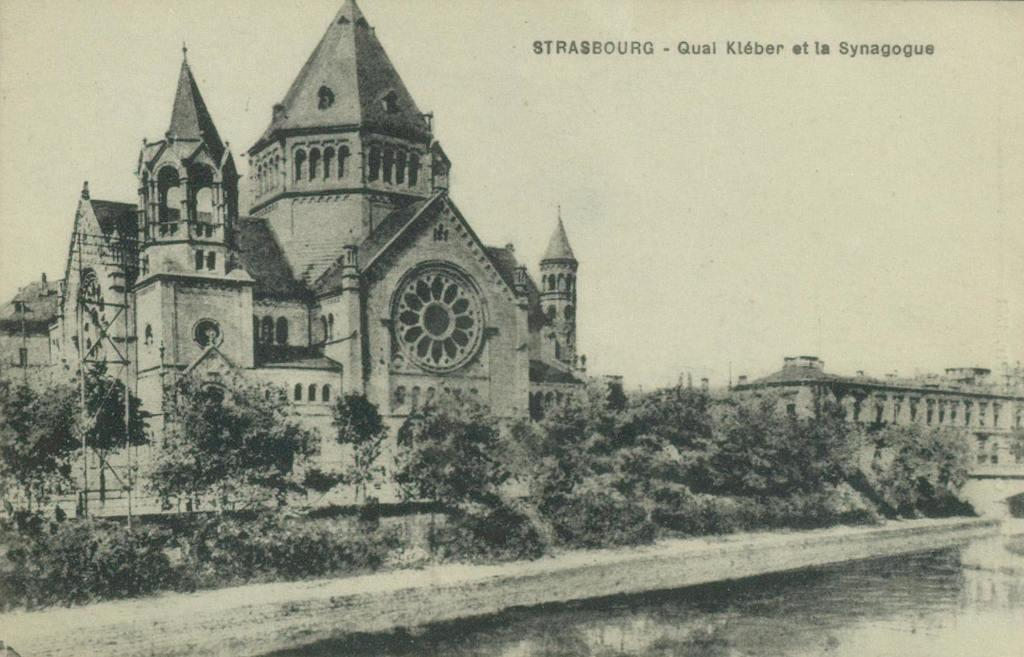What is the color scheme of the image? The image is black and white. What type of structures can be seen in the image? There are buildings in the image. What natural elements are present in the image? There are trees and water visible in the image. What is visible in the background of the image? The sky is visible in the background of the image. Are there any words or letters in the image? Yes, there is text present in the image. What type of pump is being used to create the snow in the image? There is no pump or snow present in the image; it is a black and white image featuring buildings, trees, water, and text. 